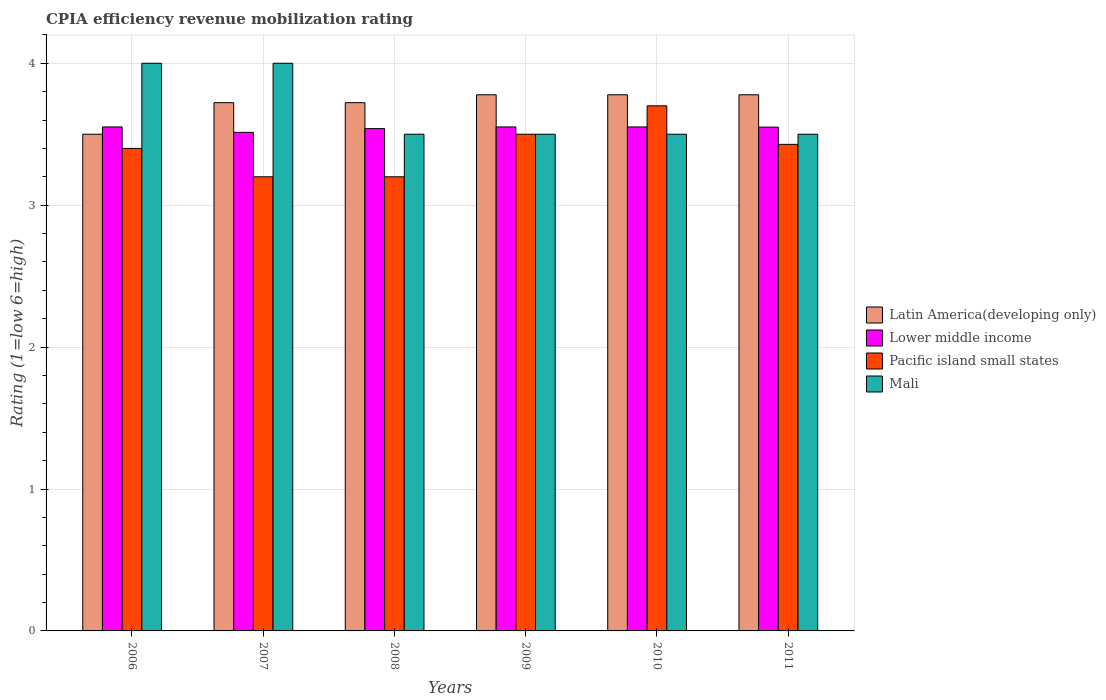How many different coloured bars are there?
Offer a very short reply. 4. How many groups of bars are there?
Give a very brief answer. 6. What is the label of the 1st group of bars from the left?
Make the answer very short. 2006. In how many cases, is the number of bars for a given year not equal to the number of legend labels?
Give a very brief answer. 0. Across all years, what is the maximum CPIA rating in Mali?
Provide a succinct answer. 4. Across all years, what is the minimum CPIA rating in Lower middle income?
Make the answer very short. 3.51. In which year was the CPIA rating in Mali maximum?
Provide a succinct answer. 2006. What is the total CPIA rating in Latin America(developing only) in the graph?
Provide a short and direct response. 22.28. What is the difference between the CPIA rating in Pacific island small states in 2009 and that in 2010?
Your answer should be very brief. -0.2. What is the difference between the CPIA rating in Lower middle income in 2007 and the CPIA rating in Mali in 2011?
Provide a short and direct response. 0.01. What is the average CPIA rating in Mali per year?
Your response must be concise. 3.67. In the year 2011, what is the difference between the CPIA rating in Pacific island small states and CPIA rating in Lower middle income?
Offer a very short reply. -0.12. In how many years, is the CPIA rating in Pacific island small states greater than 0.4?
Provide a short and direct response. 6. What is the ratio of the CPIA rating in Latin America(developing only) in 2007 to that in 2010?
Your answer should be compact. 0.99. Is the CPIA rating in Mali in 2007 less than that in 2010?
Ensure brevity in your answer.  No. What is the difference between the highest and the second highest CPIA rating in Pacific island small states?
Provide a short and direct response. 0.2. What is the difference between the highest and the lowest CPIA rating in Mali?
Offer a terse response. 0.5. What does the 1st bar from the left in 2008 represents?
Offer a very short reply. Latin America(developing only). What does the 3rd bar from the right in 2007 represents?
Make the answer very short. Lower middle income. Are all the bars in the graph horizontal?
Provide a succinct answer. No. What is the difference between two consecutive major ticks on the Y-axis?
Provide a succinct answer. 1. Are the values on the major ticks of Y-axis written in scientific E-notation?
Keep it short and to the point. No. Does the graph contain grids?
Provide a succinct answer. Yes. Where does the legend appear in the graph?
Your answer should be compact. Center right. What is the title of the graph?
Keep it short and to the point. CPIA efficiency revenue mobilization rating. What is the Rating (1=low 6=high) of Latin America(developing only) in 2006?
Offer a very short reply. 3.5. What is the Rating (1=low 6=high) in Lower middle income in 2006?
Keep it short and to the point. 3.55. What is the Rating (1=low 6=high) in Latin America(developing only) in 2007?
Your answer should be compact. 3.72. What is the Rating (1=low 6=high) in Lower middle income in 2007?
Keep it short and to the point. 3.51. What is the Rating (1=low 6=high) in Pacific island small states in 2007?
Offer a very short reply. 3.2. What is the Rating (1=low 6=high) in Latin America(developing only) in 2008?
Your answer should be compact. 3.72. What is the Rating (1=low 6=high) in Lower middle income in 2008?
Ensure brevity in your answer.  3.54. What is the Rating (1=low 6=high) in Pacific island small states in 2008?
Your answer should be very brief. 3.2. What is the Rating (1=low 6=high) in Mali in 2008?
Offer a terse response. 3.5. What is the Rating (1=low 6=high) of Latin America(developing only) in 2009?
Provide a succinct answer. 3.78. What is the Rating (1=low 6=high) of Lower middle income in 2009?
Make the answer very short. 3.55. What is the Rating (1=low 6=high) in Mali in 2009?
Give a very brief answer. 3.5. What is the Rating (1=low 6=high) of Latin America(developing only) in 2010?
Ensure brevity in your answer.  3.78. What is the Rating (1=low 6=high) of Lower middle income in 2010?
Give a very brief answer. 3.55. What is the Rating (1=low 6=high) in Pacific island small states in 2010?
Your answer should be compact. 3.7. What is the Rating (1=low 6=high) in Latin America(developing only) in 2011?
Give a very brief answer. 3.78. What is the Rating (1=low 6=high) of Lower middle income in 2011?
Give a very brief answer. 3.55. What is the Rating (1=low 6=high) of Pacific island small states in 2011?
Your answer should be compact. 3.43. What is the Rating (1=low 6=high) of Mali in 2011?
Ensure brevity in your answer.  3.5. Across all years, what is the maximum Rating (1=low 6=high) in Latin America(developing only)?
Offer a very short reply. 3.78. Across all years, what is the maximum Rating (1=low 6=high) of Lower middle income?
Make the answer very short. 3.55. Across all years, what is the maximum Rating (1=low 6=high) in Pacific island small states?
Keep it short and to the point. 3.7. Across all years, what is the maximum Rating (1=low 6=high) in Mali?
Keep it short and to the point. 4. Across all years, what is the minimum Rating (1=low 6=high) in Lower middle income?
Provide a short and direct response. 3.51. Across all years, what is the minimum Rating (1=low 6=high) of Mali?
Your answer should be compact. 3.5. What is the total Rating (1=low 6=high) in Latin America(developing only) in the graph?
Make the answer very short. 22.28. What is the total Rating (1=low 6=high) in Lower middle income in the graph?
Your answer should be compact. 21.26. What is the total Rating (1=low 6=high) of Pacific island small states in the graph?
Provide a short and direct response. 20.43. What is the total Rating (1=low 6=high) of Mali in the graph?
Your answer should be very brief. 22. What is the difference between the Rating (1=low 6=high) of Latin America(developing only) in 2006 and that in 2007?
Give a very brief answer. -0.22. What is the difference between the Rating (1=low 6=high) of Lower middle income in 2006 and that in 2007?
Make the answer very short. 0.04. What is the difference between the Rating (1=low 6=high) in Mali in 2006 and that in 2007?
Keep it short and to the point. 0. What is the difference between the Rating (1=low 6=high) in Latin America(developing only) in 2006 and that in 2008?
Offer a terse response. -0.22. What is the difference between the Rating (1=low 6=high) of Lower middle income in 2006 and that in 2008?
Keep it short and to the point. 0.01. What is the difference between the Rating (1=low 6=high) of Latin America(developing only) in 2006 and that in 2009?
Make the answer very short. -0.28. What is the difference between the Rating (1=low 6=high) in Lower middle income in 2006 and that in 2009?
Your answer should be compact. 0. What is the difference between the Rating (1=low 6=high) in Pacific island small states in 2006 and that in 2009?
Make the answer very short. -0.1. What is the difference between the Rating (1=low 6=high) in Mali in 2006 and that in 2009?
Ensure brevity in your answer.  0.5. What is the difference between the Rating (1=low 6=high) in Latin America(developing only) in 2006 and that in 2010?
Your answer should be compact. -0.28. What is the difference between the Rating (1=low 6=high) of Lower middle income in 2006 and that in 2010?
Keep it short and to the point. 0. What is the difference between the Rating (1=low 6=high) in Pacific island small states in 2006 and that in 2010?
Your answer should be compact. -0.3. What is the difference between the Rating (1=low 6=high) in Latin America(developing only) in 2006 and that in 2011?
Offer a terse response. -0.28. What is the difference between the Rating (1=low 6=high) in Lower middle income in 2006 and that in 2011?
Keep it short and to the point. 0. What is the difference between the Rating (1=low 6=high) of Pacific island small states in 2006 and that in 2011?
Your answer should be very brief. -0.03. What is the difference between the Rating (1=low 6=high) of Mali in 2006 and that in 2011?
Provide a succinct answer. 0.5. What is the difference between the Rating (1=low 6=high) of Lower middle income in 2007 and that in 2008?
Your answer should be compact. -0.03. What is the difference between the Rating (1=low 6=high) in Latin America(developing only) in 2007 and that in 2009?
Provide a succinct answer. -0.06. What is the difference between the Rating (1=low 6=high) of Lower middle income in 2007 and that in 2009?
Your answer should be compact. -0.04. What is the difference between the Rating (1=low 6=high) of Pacific island small states in 2007 and that in 2009?
Provide a short and direct response. -0.3. What is the difference between the Rating (1=low 6=high) of Mali in 2007 and that in 2009?
Your answer should be very brief. 0.5. What is the difference between the Rating (1=low 6=high) of Latin America(developing only) in 2007 and that in 2010?
Give a very brief answer. -0.06. What is the difference between the Rating (1=low 6=high) of Lower middle income in 2007 and that in 2010?
Your answer should be very brief. -0.04. What is the difference between the Rating (1=low 6=high) of Pacific island small states in 2007 and that in 2010?
Your answer should be very brief. -0.5. What is the difference between the Rating (1=low 6=high) of Mali in 2007 and that in 2010?
Offer a terse response. 0.5. What is the difference between the Rating (1=low 6=high) in Latin America(developing only) in 2007 and that in 2011?
Provide a succinct answer. -0.06. What is the difference between the Rating (1=low 6=high) of Lower middle income in 2007 and that in 2011?
Make the answer very short. -0.04. What is the difference between the Rating (1=low 6=high) in Pacific island small states in 2007 and that in 2011?
Give a very brief answer. -0.23. What is the difference between the Rating (1=low 6=high) of Mali in 2007 and that in 2011?
Your answer should be compact. 0.5. What is the difference between the Rating (1=low 6=high) in Latin America(developing only) in 2008 and that in 2009?
Your answer should be very brief. -0.06. What is the difference between the Rating (1=low 6=high) in Lower middle income in 2008 and that in 2009?
Keep it short and to the point. -0.01. What is the difference between the Rating (1=low 6=high) in Latin America(developing only) in 2008 and that in 2010?
Keep it short and to the point. -0.06. What is the difference between the Rating (1=low 6=high) in Lower middle income in 2008 and that in 2010?
Keep it short and to the point. -0.01. What is the difference between the Rating (1=low 6=high) of Mali in 2008 and that in 2010?
Your answer should be very brief. 0. What is the difference between the Rating (1=low 6=high) in Latin America(developing only) in 2008 and that in 2011?
Your response must be concise. -0.06. What is the difference between the Rating (1=low 6=high) of Lower middle income in 2008 and that in 2011?
Offer a very short reply. -0.01. What is the difference between the Rating (1=low 6=high) of Pacific island small states in 2008 and that in 2011?
Give a very brief answer. -0.23. What is the difference between the Rating (1=low 6=high) of Mali in 2008 and that in 2011?
Make the answer very short. 0. What is the difference between the Rating (1=low 6=high) of Mali in 2009 and that in 2010?
Give a very brief answer. 0. What is the difference between the Rating (1=low 6=high) in Latin America(developing only) in 2009 and that in 2011?
Your answer should be very brief. 0. What is the difference between the Rating (1=low 6=high) in Lower middle income in 2009 and that in 2011?
Your answer should be very brief. 0. What is the difference between the Rating (1=low 6=high) of Pacific island small states in 2009 and that in 2011?
Keep it short and to the point. 0.07. What is the difference between the Rating (1=low 6=high) of Latin America(developing only) in 2010 and that in 2011?
Your answer should be very brief. 0. What is the difference between the Rating (1=low 6=high) in Lower middle income in 2010 and that in 2011?
Offer a very short reply. 0. What is the difference between the Rating (1=low 6=high) of Pacific island small states in 2010 and that in 2011?
Your answer should be very brief. 0.27. What is the difference between the Rating (1=low 6=high) in Mali in 2010 and that in 2011?
Ensure brevity in your answer.  0. What is the difference between the Rating (1=low 6=high) of Latin America(developing only) in 2006 and the Rating (1=low 6=high) of Lower middle income in 2007?
Give a very brief answer. -0.01. What is the difference between the Rating (1=low 6=high) in Latin America(developing only) in 2006 and the Rating (1=low 6=high) in Pacific island small states in 2007?
Provide a short and direct response. 0.3. What is the difference between the Rating (1=low 6=high) of Latin America(developing only) in 2006 and the Rating (1=low 6=high) of Mali in 2007?
Your response must be concise. -0.5. What is the difference between the Rating (1=low 6=high) of Lower middle income in 2006 and the Rating (1=low 6=high) of Pacific island small states in 2007?
Make the answer very short. 0.35. What is the difference between the Rating (1=low 6=high) in Lower middle income in 2006 and the Rating (1=low 6=high) in Mali in 2007?
Your answer should be compact. -0.45. What is the difference between the Rating (1=low 6=high) of Pacific island small states in 2006 and the Rating (1=low 6=high) of Mali in 2007?
Provide a succinct answer. -0.6. What is the difference between the Rating (1=low 6=high) in Latin America(developing only) in 2006 and the Rating (1=low 6=high) in Lower middle income in 2008?
Ensure brevity in your answer.  -0.04. What is the difference between the Rating (1=low 6=high) in Latin America(developing only) in 2006 and the Rating (1=low 6=high) in Pacific island small states in 2008?
Your answer should be compact. 0.3. What is the difference between the Rating (1=low 6=high) in Latin America(developing only) in 2006 and the Rating (1=low 6=high) in Mali in 2008?
Keep it short and to the point. 0. What is the difference between the Rating (1=low 6=high) of Lower middle income in 2006 and the Rating (1=low 6=high) of Pacific island small states in 2008?
Provide a short and direct response. 0.35. What is the difference between the Rating (1=low 6=high) in Lower middle income in 2006 and the Rating (1=low 6=high) in Mali in 2008?
Offer a terse response. 0.05. What is the difference between the Rating (1=low 6=high) of Pacific island small states in 2006 and the Rating (1=low 6=high) of Mali in 2008?
Give a very brief answer. -0.1. What is the difference between the Rating (1=low 6=high) of Latin America(developing only) in 2006 and the Rating (1=low 6=high) of Lower middle income in 2009?
Offer a very short reply. -0.05. What is the difference between the Rating (1=low 6=high) in Lower middle income in 2006 and the Rating (1=low 6=high) in Pacific island small states in 2009?
Give a very brief answer. 0.05. What is the difference between the Rating (1=low 6=high) of Lower middle income in 2006 and the Rating (1=low 6=high) of Mali in 2009?
Your answer should be compact. 0.05. What is the difference between the Rating (1=low 6=high) of Latin America(developing only) in 2006 and the Rating (1=low 6=high) of Lower middle income in 2010?
Make the answer very short. -0.05. What is the difference between the Rating (1=low 6=high) in Lower middle income in 2006 and the Rating (1=low 6=high) in Pacific island small states in 2010?
Your response must be concise. -0.15. What is the difference between the Rating (1=low 6=high) in Lower middle income in 2006 and the Rating (1=low 6=high) in Mali in 2010?
Your answer should be compact. 0.05. What is the difference between the Rating (1=low 6=high) of Pacific island small states in 2006 and the Rating (1=low 6=high) of Mali in 2010?
Make the answer very short. -0.1. What is the difference between the Rating (1=low 6=high) of Latin America(developing only) in 2006 and the Rating (1=low 6=high) of Pacific island small states in 2011?
Make the answer very short. 0.07. What is the difference between the Rating (1=low 6=high) of Latin America(developing only) in 2006 and the Rating (1=low 6=high) of Mali in 2011?
Provide a short and direct response. 0. What is the difference between the Rating (1=low 6=high) in Lower middle income in 2006 and the Rating (1=low 6=high) in Pacific island small states in 2011?
Your answer should be compact. 0.12. What is the difference between the Rating (1=low 6=high) of Lower middle income in 2006 and the Rating (1=low 6=high) of Mali in 2011?
Offer a terse response. 0.05. What is the difference between the Rating (1=low 6=high) of Latin America(developing only) in 2007 and the Rating (1=low 6=high) of Lower middle income in 2008?
Give a very brief answer. 0.18. What is the difference between the Rating (1=low 6=high) in Latin America(developing only) in 2007 and the Rating (1=low 6=high) in Pacific island small states in 2008?
Keep it short and to the point. 0.52. What is the difference between the Rating (1=low 6=high) of Latin America(developing only) in 2007 and the Rating (1=low 6=high) of Mali in 2008?
Provide a short and direct response. 0.22. What is the difference between the Rating (1=low 6=high) in Lower middle income in 2007 and the Rating (1=low 6=high) in Pacific island small states in 2008?
Offer a terse response. 0.31. What is the difference between the Rating (1=low 6=high) in Lower middle income in 2007 and the Rating (1=low 6=high) in Mali in 2008?
Offer a very short reply. 0.01. What is the difference between the Rating (1=low 6=high) of Latin America(developing only) in 2007 and the Rating (1=low 6=high) of Lower middle income in 2009?
Keep it short and to the point. 0.17. What is the difference between the Rating (1=low 6=high) in Latin America(developing only) in 2007 and the Rating (1=low 6=high) in Pacific island small states in 2009?
Your answer should be compact. 0.22. What is the difference between the Rating (1=low 6=high) of Latin America(developing only) in 2007 and the Rating (1=low 6=high) of Mali in 2009?
Keep it short and to the point. 0.22. What is the difference between the Rating (1=low 6=high) in Lower middle income in 2007 and the Rating (1=low 6=high) in Pacific island small states in 2009?
Ensure brevity in your answer.  0.01. What is the difference between the Rating (1=low 6=high) of Lower middle income in 2007 and the Rating (1=low 6=high) of Mali in 2009?
Keep it short and to the point. 0.01. What is the difference between the Rating (1=low 6=high) of Pacific island small states in 2007 and the Rating (1=low 6=high) of Mali in 2009?
Ensure brevity in your answer.  -0.3. What is the difference between the Rating (1=low 6=high) of Latin America(developing only) in 2007 and the Rating (1=low 6=high) of Lower middle income in 2010?
Make the answer very short. 0.17. What is the difference between the Rating (1=low 6=high) of Latin America(developing only) in 2007 and the Rating (1=low 6=high) of Pacific island small states in 2010?
Offer a very short reply. 0.02. What is the difference between the Rating (1=low 6=high) in Latin America(developing only) in 2007 and the Rating (1=low 6=high) in Mali in 2010?
Ensure brevity in your answer.  0.22. What is the difference between the Rating (1=low 6=high) in Lower middle income in 2007 and the Rating (1=low 6=high) in Pacific island small states in 2010?
Provide a succinct answer. -0.19. What is the difference between the Rating (1=low 6=high) in Lower middle income in 2007 and the Rating (1=low 6=high) in Mali in 2010?
Ensure brevity in your answer.  0.01. What is the difference between the Rating (1=low 6=high) of Pacific island small states in 2007 and the Rating (1=low 6=high) of Mali in 2010?
Keep it short and to the point. -0.3. What is the difference between the Rating (1=low 6=high) of Latin America(developing only) in 2007 and the Rating (1=low 6=high) of Lower middle income in 2011?
Provide a succinct answer. 0.17. What is the difference between the Rating (1=low 6=high) of Latin America(developing only) in 2007 and the Rating (1=low 6=high) of Pacific island small states in 2011?
Ensure brevity in your answer.  0.29. What is the difference between the Rating (1=low 6=high) of Latin America(developing only) in 2007 and the Rating (1=low 6=high) of Mali in 2011?
Keep it short and to the point. 0.22. What is the difference between the Rating (1=low 6=high) of Lower middle income in 2007 and the Rating (1=low 6=high) of Pacific island small states in 2011?
Offer a very short reply. 0.08. What is the difference between the Rating (1=low 6=high) of Lower middle income in 2007 and the Rating (1=low 6=high) of Mali in 2011?
Provide a succinct answer. 0.01. What is the difference between the Rating (1=low 6=high) in Pacific island small states in 2007 and the Rating (1=low 6=high) in Mali in 2011?
Your answer should be compact. -0.3. What is the difference between the Rating (1=low 6=high) of Latin America(developing only) in 2008 and the Rating (1=low 6=high) of Lower middle income in 2009?
Ensure brevity in your answer.  0.17. What is the difference between the Rating (1=low 6=high) of Latin America(developing only) in 2008 and the Rating (1=low 6=high) of Pacific island small states in 2009?
Give a very brief answer. 0.22. What is the difference between the Rating (1=low 6=high) of Latin America(developing only) in 2008 and the Rating (1=low 6=high) of Mali in 2009?
Keep it short and to the point. 0.22. What is the difference between the Rating (1=low 6=high) of Lower middle income in 2008 and the Rating (1=low 6=high) of Pacific island small states in 2009?
Provide a short and direct response. 0.04. What is the difference between the Rating (1=low 6=high) in Lower middle income in 2008 and the Rating (1=low 6=high) in Mali in 2009?
Make the answer very short. 0.04. What is the difference between the Rating (1=low 6=high) in Latin America(developing only) in 2008 and the Rating (1=low 6=high) in Lower middle income in 2010?
Ensure brevity in your answer.  0.17. What is the difference between the Rating (1=low 6=high) of Latin America(developing only) in 2008 and the Rating (1=low 6=high) of Pacific island small states in 2010?
Provide a succinct answer. 0.02. What is the difference between the Rating (1=low 6=high) of Latin America(developing only) in 2008 and the Rating (1=low 6=high) of Mali in 2010?
Give a very brief answer. 0.22. What is the difference between the Rating (1=low 6=high) of Lower middle income in 2008 and the Rating (1=low 6=high) of Pacific island small states in 2010?
Your response must be concise. -0.16. What is the difference between the Rating (1=low 6=high) of Lower middle income in 2008 and the Rating (1=low 6=high) of Mali in 2010?
Offer a terse response. 0.04. What is the difference between the Rating (1=low 6=high) of Pacific island small states in 2008 and the Rating (1=low 6=high) of Mali in 2010?
Ensure brevity in your answer.  -0.3. What is the difference between the Rating (1=low 6=high) of Latin America(developing only) in 2008 and the Rating (1=low 6=high) of Lower middle income in 2011?
Give a very brief answer. 0.17. What is the difference between the Rating (1=low 6=high) in Latin America(developing only) in 2008 and the Rating (1=low 6=high) in Pacific island small states in 2011?
Give a very brief answer. 0.29. What is the difference between the Rating (1=low 6=high) in Latin America(developing only) in 2008 and the Rating (1=low 6=high) in Mali in 2011?
Your answer should be compact. 0.22. What is the difference between the Rating (1=low 6=high) of Lower middle income in 2008 and the Rating (1=low 6=high) of Pacific island small states in 2011?
Ensure brevity in your answer.  0.11. What is the difference between the Rating (1=low 6=high) of Lower middle income in 2008 and the Rating (1=low 6=high) of Mali in 2011?
Give a very brief answer. 0.04. What is the difference between the Rating (1=low 6=high) in Pacific island small states in 2008 and the Rating (1=low 6=high) in Mali in 2011?
Give a very brief answer. -0.3. What is the difference between the Rating (1=low 6=high) of Latin America(developing only) in 2009 and the Rating (1=low 6=high) of Lower middle income in 2010?
Offer a very short reply. 0.23. What is the difference between the Rating (1=low 6=high) in Latin America(developing only) in 2009 and the Rating (1=low 6=high) in Pacific island small states in 2010?
Provide a succinct answer. 0.08. What is the difference between the Rating (1=low 6=high) of Latin America(developing only) in 2009 and the Rating (1=low 6=high) of Mali in 2010?
Ensure brevity in your answer.  0.28. What is the difference between the Rating (1=low 6=high) in Lower middle income in 2009 and the Rating (1=low 6=high) in Pacific island small states in 2010?
Your answer should be compact. -0.15. What is the difference between the Rating (1=low 6=high) of Lower middle income in 2009 and the Rating (1=low 6=high) of Mali in 2010?
Provide a short and direct response. 0.05. What is the difference between the Rating (1=low 6=high) of Latin America(developing only) in 2009 and the Rating (1=low 6=high) of Lower middle income in 2011?
Your response must be concise. 0.23. What is the difference between the Rating (1=low 6=high) in Latin America(developing only) in 2009 and the Rating (1=low 6=high) in Pacific island small states in 2011?
Your answer should be very brief. 0.35. What is the difference between the Rating (1=low 6=high) of Latin America(developing only) in 2009 and the Rating (1=low 6=high) of Mali in 2011?
Your answer should be very brief. 0.28. What is the difference between the Rating (1=low 6=high) in Lower middle income in 2009 and the Rating (1=low 6=high) in Pacific island small states in 2011?
Offer a terse response. 0.12. What is the difference between the Rating (1=low 6=high) of Lower middle income in 2009 and the Rating (1=low 6=high) of Mali in 2011?
Ensure brevity in your answer.  0.05. What is the difference between the Rating (1=low 6=high) of Latin America(developing only) in 2010 and the Rating (1=low 6=high) of Lower middle income in 2011?
Offer a very short reply. 0.23. What is the difference between the Rating (1=low 6=high) of Latin America(developing only) in 2010 and the Rating (1=low 6=high) of Pacific island small states in 2011?
Provide a short and direct response. 0.35. What is the difference between the Rating (1=low 6=high) of Latin America(developing only) in 2010 and the Rating (1=low 6=high) of Mali in 2011?
Keep it short and to the point. 0.28. What is the difference between the Rating (1=low 6=high) of Lower middle income in 2010 and the Rating (1=low 6=high) of Pacific island small states in 2011?
Keep it short and to the point. 0.12. What is the difference between the Rating (1=low 6=high) of Lower middle income in 2010 and the Rating (1=low 6=high) of Mali in 2011?
Keep it short and to the point. 0.05. What is the difference between the Rating (1=low 6=high) of Pacific island small states in 2010 and the Rating (1=low 6=high) of Mali in 2011?
Provide a succinct answer. 0.2. What is the average Rating (1=low 6=high) of Latin America(developing only) per year?
Ensure brevity in your answer.  3.71. What is the average Rating (1=low 6=high) in Lower middle income per year?
Ensure brevity in your answer.  3.54. What is the average Rating (1=low 6=high) of Pacific island small states per year?
Your answer should be compact. 3.4. What is the average Rating (1=low 6=high) of Mali per year?
Your answer should be very brief. 3.67. In the year 2006, what is the difference between the Rating (1=low 6=high) of Latin America(developing only) and Rating (1=low 6=high) of Lower middle income?
Provide a short and direct response. -0.05. In the year 2006, what is the difference between the Rating (1=low 6=high) of Latin America(developing only) and Rating (1=low 6=high) of Pacific island small states?
Give a very brief answer. 0.1. In the year 2006, what is the difference between the Rating (1=low 6=high) of Lower middle income and Rating (1=low 6=high) of Pacific island small states?
Give a very brief answer. 0.15. In the year 2006, what is the difference between the Rating (1=low 6=high) of Lower middle income and Rating (1=low 6=high) of Mali?
Give a very brief answer. -0.45. In the year 2006, what is the difference between the Rating (1=low 6=high) in Pacific island small states and Rating (1=low 6=high) in Mali?
Ensure brevity in your answer.  -0.6. In the year 2007, what is the difference between the Rating (1=low 6=high) of Latin America(developing only) and Rating (1=low 6=high) of Lower middle income?
Offer a terse response. 0.21. In the year 2007, what is the difference between the Rating (1=low 6=high) of Latin America(developing only) and Rating (1=low 6=high) of Pacific island small states?
Offer a very short reply. 0.52. In the year 2007, what is the difference between the Rating (1=low 6=high) of Latin America(developing only) and Rating (1=low 6=high) of Mali?
Offer a terse response. -0.28. In the year 2007, what is the difference between the Rating (1=low 6=high) in Lower middle income and Rating (1=low 6=high) in Pacific island small states?
Provide a short and direct response. 0.31. In the year 2007, what is the difference between the Rating (1=low 6=high) of Lower middle income and Rating (1=low 6=high) of Mali?
Your response must be concise. -0.49. In the year 2008, what is the difference between the Rating (1=low 6=high) of Latin America(developing only) and Rating (1=low 6=high) of Lower middle income?
Your answer should be very brief. 0.18. In the year 2008, what is the difference between the Rating (1=low 6=high) of Latin America(developing only) and Rating (1=low 6=high) of Pacific island small states?
Keep it short and to the point. 0.52. In the year 2008, what is the difference between the Rating (1=low 6=high) of Latin America(developing only) and Rating (1=low 6=high) of Mali?
Ensure brevity in your answer.  0.22. In the year 2008, what is the difference between the Rating (1=low 6=high) of Lower middle income and Rating (1=low 6=high) of Pacific island small states?
Your answer should be compact. 0.34. In the year 2008, what is the difference between the Rating (1=low 6=high) of Lower middle income and Rating (1=low 6=high) of Mali?
Keep it short and to the point. 0.04. In the year 2009, what is the difference between the Rating (1=low 6=high) of Latin America(developing only) and Rating (1=low 6=high) of Lower middle income?
Offer a very short reply. 0.23. In the year 2009, what is the difference between the Rating (1=low 6=high) in Latin America(developing only) and Rating (1=low 6=high) in Pacific island small states?
Keep it short and to the point. 0.28. In the year 2009, what is the difference between the Rating (1=low 6=high) of Latin America(developing only) and Rating (1=low 6=high) of Mali?
Offer a very short reply. 0.28. In the year 2009, what is the difference between the Rating (1=low 6=high) of Lower middle income and Rating (1=low 6=high) of Pacific island small states?
Offer a terse response. 0.05. In the year 2009, what is the difference between the Rating (1=low 6=high) of Lower middle income and Rating (1=low 6=high) of Mali?
Provide a short and direct response. 0.05. In the year 2010, what is the difference between the Rating (1=low 6=high) in Latin America(developing only) and Rating (1=low 6=high) in Lower middle income?
Provide a short and direct response. 0.23. In the year 2010, what is the difference between the Rating (1=low 6=high) of Latin America(developing only) and Rating (1=low 6=high) of Pacific island small states?
Keep it short and to the point. 0.08. In the year 2010, what is the difference between the Rating (1=low 6=high) in Latin America(developing only) and Rating (1=low 6=high) in Mali?
Give a very brief answer. 0.28. In the year 2010, what is the difference between the Rating (1=low 6=high) in Lower middle income and Rating (1=low 6=high) in Pacific island small states?
Keep it short and to the point. -0.15. In the year 2010, what is the difference between the Rating (1=low 6=high) in Lower middle income and Rating (1=low 6=high) in Mali?
Offer a terse response. 0.05. In the year 2011, what is the difference between the Rating (1=low 6=high) of Latin America(developing only) and Rating (1=low 6=high) of Lower middle income?
Your answer should be very brief. 0.23. In the year 2011, what is the difference between the Rating (1=low 6=high) in Latin America(developing only) and Rating (1=low 6=high) in Pacific island small states?
Offer a terse response. 0.35. In the year 2011, what is the difference between the Rating (1=low 6=high) of Latin America(developing only) and Rating (1=low 6=high) of Mali?
Your answer should be compact. 0.28. In the year 2011, what is the difference between the Rating (1=low 6=high) in Lower middle income and Rating (1=low 6=high) in Pacific island small states?
Provide a short and direct response. 0.12. In the year 2011, what is the difference between the Rating (1=low 6=high) in Pacific island small states and Rating (1=low 6=high) in Mali?
Offer a very short reply. -0.07. What is the ratio of the Rating (1=low 6=high) in Latin America(developing only) in 2006 to that in 2007?
Provide a short and direct response. 0.94. What is the ratio of the Rating (1=low 6=high) in Lower middle income in 2006 to that in 2007?
Offer a very short reply. 1.01. What is the ratio of the Rating (1=low 6=high) in Pacific island small states in 2006 to that in 2007?
Your response must be concise. 1.06. What is the ratio of the Rating (1=low 6=high) of Mali in 2006 to that in 2007?
Offer a very short reply. 1. What is the ratio of the Rating (1=low 6=high) in Latin America(developing only) in 2006 to that in 2008?
Provide a succinct answer. 0.94. What is the ratio of the Rating (1=low 6=high) in Latin America(developing only) in 2006 to that in 2009?
Your answer should be compact. 0.93. What is the ratio of the Rating (1=low 6=high) in Pacific island small states in 2006 to that in 2009?
Provide a succinct answer. 0.97. What is the ratio of the Rating (1=low 6=high) of Mali in 2006 to that in 2009?
Offer a very short reply. 1.14. What is the ratio of the Rating (1=low 6=high) in Latin America(developing only) in 2006 to that in 2010?
Provide a short and direct response. 0.93. What is the ratio of the Rating (1=low 6=high) of Lower middle income in 2006 to that in 2010?
Provide a succinct answer. 1. What is the ratio of the Rating (1=low 6=high) of Pacific island small states in 2006 to that in 2010?
Your answer should be very brief. 0.92. What is the ratio of the Rating (1=low 6=high) of Latin America(developing only) in 2006 to that in 2011?
Offer a terse response. 0.93. What is the ratio of the Rating (1=low 6=high) of Pacific island small states in 2006 to that in 2011?
Give a very brief answer. 0.99. What is the ratio of the Rating (1=low 6=high) in Mali in 2006 to that in 2011?
Ensure brevity in your answer.  1.14. What is the ratio of the Rating (1=low 6=high) of Latin America(developing only) in 2007 to that in 2009?
Keep it short and to the point. 0.99. What is the ratio of the Rating (1=low 6=high) in Lower middle income in 2007 to that in 2009?
Your answer should be very brief. 0.99. What is the ratio of the Rating (1=low 6=high) of Pacific island small states in 2007 to that in 2009?
Your response must be concise. 0.91. What is the ratio of the Rating (1=low 6=high) in Latin America(developing only) in 2007 to that in 2010?
Give a very brief answer. 0.99. What is the ratio of the Rating (1=low 6=high) in Lower middle income in 2007 to that in 2010?
Keep it short and to the point. 0.99. What is the ratio of the Rating (1=low 6=high) in Pacific island small states in 2007 to that in 2010?
Provide a succinct answer. 0.86. What is the ratio of the Rating (1=low 6=high) of Mali in 2007 to that in 2011?
Provide a short and direct response. 1.14. What is the ratio of the Rating (1=low 6=high) in Latin America(developing only) in 2008 to that in 2009?
Offer a very short reply. 0.99. What is the ratio of the Rating (1=low 6=high) of Pacific island small states in 2008 to that in 2009?
Your answer should be compact. 0.91. What is the ratio of the Rating (1=low 6=high) of Mali in 2008 to that in 2009?
Offer a very short reply. 1. What is the ratio of the Rating (1=low 6=high) in Latin America(developing only) in 2008 to that in 2010?
Provide a short and direct response. 0.99. What is the ratio of the Rating (1=low 6=high) of Lower middle income in 2008 to that in 2010?
Your answer should be very brief. 1. What is the ratio of the Rating (1=low 6=high) in Pacific island small states in 2008 to that in 2010?
Ensure brevity in your answer.  0.86. What is the ratio of the Rating (1=low 6=high) of Mali in 2008 to that in 2010?
Offer a very short reply. 1. What is the ratio of the Rating (1=low 6=high) of Lower middle income in 2008 to that in 2011?
Make the answer very short. 1. What is the ratio of the Rating (1=low 6=high) of Pacific island small states in 2008 to that in 2011?
Offer a very short reply. 0.93. What is the ratio of the Rating (1=low 6=high) in Pacific island small states in 2009 to that in 2010?
Your answer should be compact. 0.95. What is the ratio of the Rating (1=low 6=high) of Mali in 2009 to that in 2010?
Provide a short and direct response. 1. What is the ratio of the Rating (1=low 6=high) of Pacific island small states in 2009 to that in 2011?
Your answer should be compact. 1.02. What is the ratio of the Rating (1=low 6=high) in Mali in 2009 to that in 2011?
Provide a succinct answer. 1. What is the ratio of the Rating (1=low 6=high) in Latin America(developing only) in 2010 to that in 2011?
Your response must be concise. 1. What is the ratio of the Rating (1=low 6=high) of Pacific island small states in 2010 to that in 2011?
Provide a short and direct response. 1.08. What is the ratio of the Rating (1=low 6=high) in Mali in 2010 to that in 2011?
Offer a terse response. 1. What is the difference between the highest and the second highest Rating (1=low 6=high) of Lower middle income?
Offer a very short reply. 0. What is the difference between the highest and the lowest Rating (1=low 6=high) in Latin America(developing only)?
Offer a very short reply. 0.28. What is the difference between the highest and the lowest Rating (1=low 6=high) in Lower middle income?
Your answer should be very brief. 0.04. What is the difference between the highest and the lowest Rating (1=low 6=high) of Mali?
Your answer should be very brief. 0.5. 